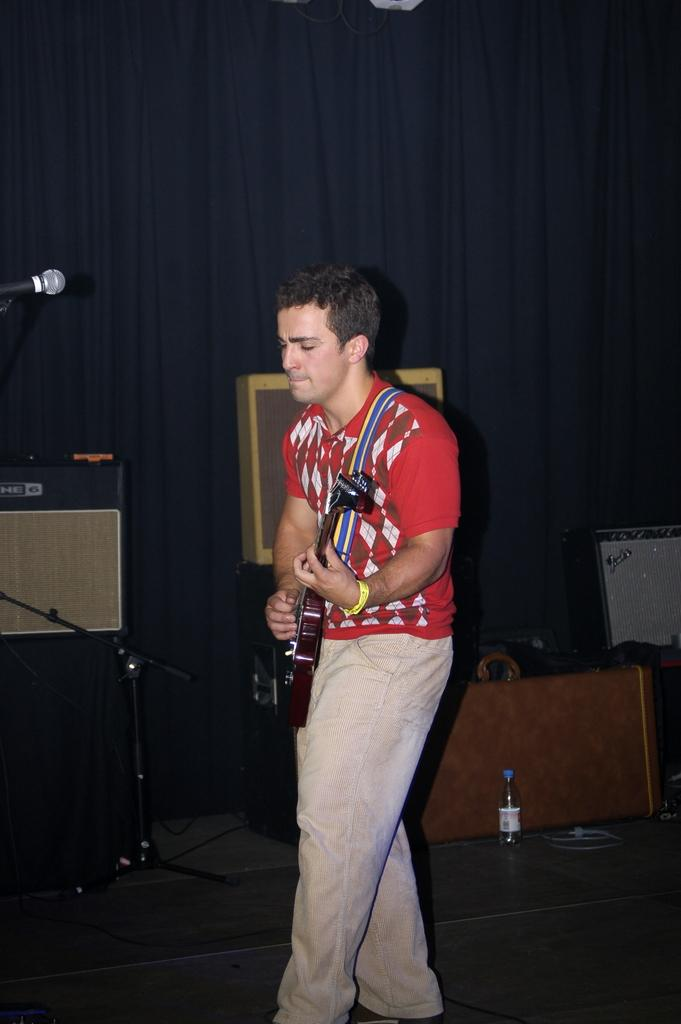What is the person in the image doing? The person is standing in the image. What object is the person holding? The person is holding a guitar. What other object is present in the image? There is a microphone in the image. What is the price of the circle in the image? There is no circle present in the image, and therefore no price can be determined. 